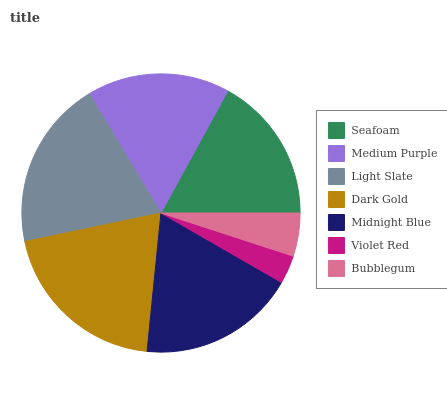Is Violet Red the minimum?
Answer yes or no. Yes. Is Dark Gold the maximum?
Answer yes or no. Yes. Is Medium Purple the minimum?
Answer yes or no. No. Is Medium Purple the maximum?
Answer yes or no. No. Is Seafoam greater than Medium Purple?
Answer yes or no. Yes. Is Medium Purple less than Seafoam?
Answer yes or no. Yes. Is Medium Purple greater than Seafoam?
Answer yes or no. No. Is Seafoam less than Medium Purple?
Answer yes or no. No. Is Seafoam the high median?
Answer yes or no. Yes. Is Seafoam the low median?
Answer yes or no. Yes. Is Light Slate the high median?
Answer yes or no. No. Is Midnight Blue the low median?
Answer yes or no. No. 